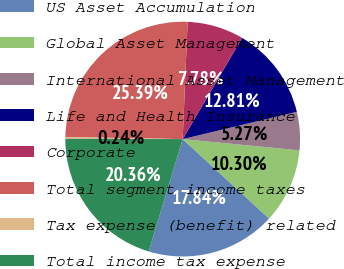Convert chart to OTSL. <chart><loc_0><loc_0><loc_500><loc_500><pie_chart><fcel>US Asset Accumulation<fcel>Global Asset Management<fcel>International Asset Management<fcel>Life and Health Insurance<fcel>Corporate<fcel>Total segment income taxes<fcel>Tax expense (benefit) related<fcel>Total income tax expense<nl><fcel>17.84%<fcel>10.3%<fcel>5.27%<fcel>12.81%<fcel>7.78%<fcel>25.39%<fcel>0.24%<fcel>20.36%<nl></chart> 